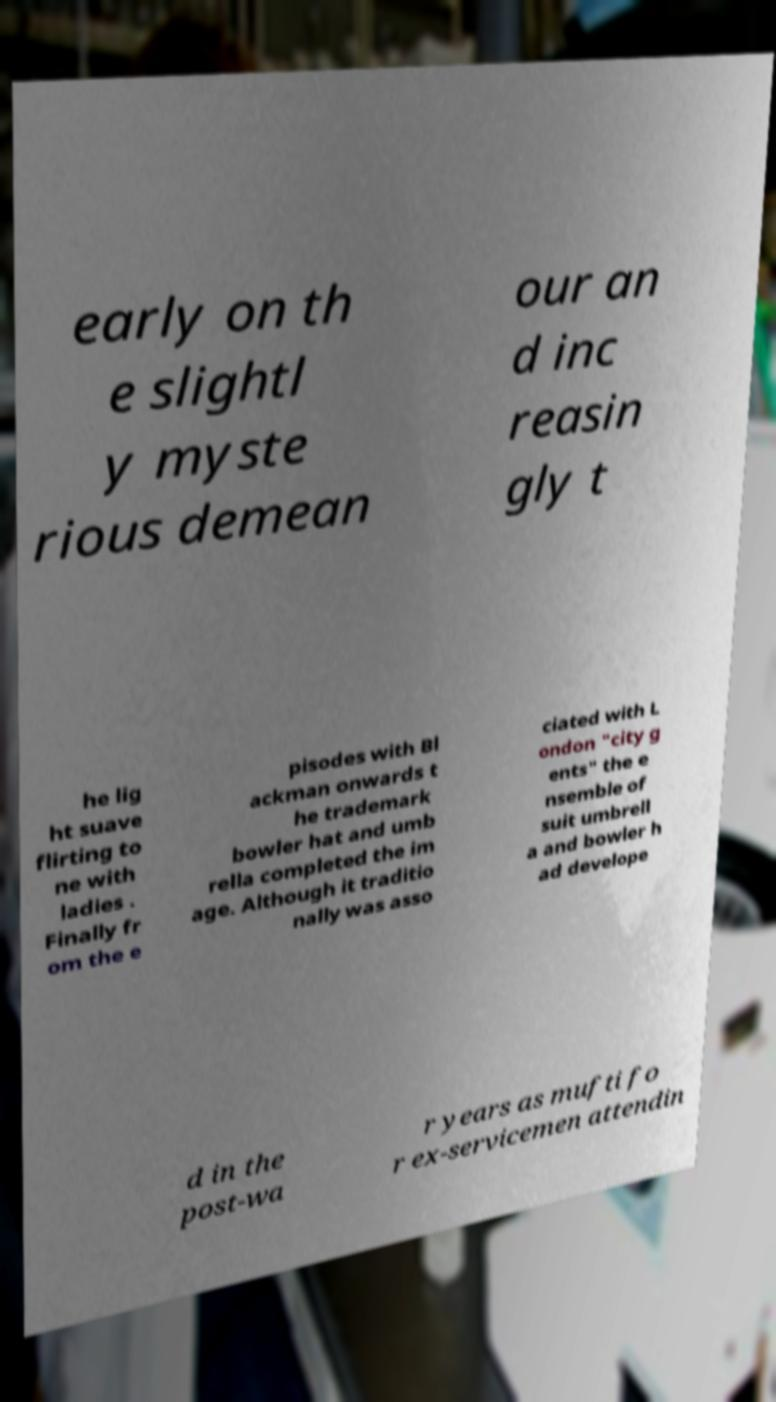I need the written content from this picture converted into text. Can you do that? early on th e slightl y myste rious demean our an d inc reasin gly t he lig ht suave flirting to ne with ladies . Finally fr om the e pisodes with Bl ackman onwards t he trademark bowler hat and umb rella completed the im age. Although it traditio nally was asso ciated with L ondon "city g ents" the e nsemble of suit umbrell a and bowler h ad develope d in the post-wa r years as mufti fo r ex-servicemen attendin 